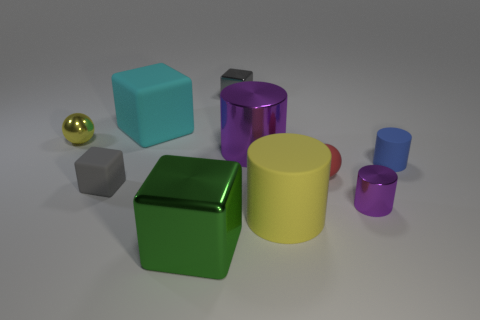Subtract all blue rubber cylinders. How many cylinders are left? 3 Subtract 2 cubes. How many cubes are left? 2 Subtract all cyan cubes. How many purple cylinders are left? 2 Subtract all blue cylinders. How many cylinders are left? 3 Subtract all spheres. How many objects are left? 8 Add 3 big yellow objects. How many big yellow objects are left? 4 Add 2 big green things. How many big green things exist? 3 Subtract 0 red blocks. How many objects are left? 10 Subtract all red cylinders. Subtract all cyan balls. How many cylinders are left? 4 Subtract all tiny cyan metal things. Subtract all tiny blue things. How many objects are left? 9 